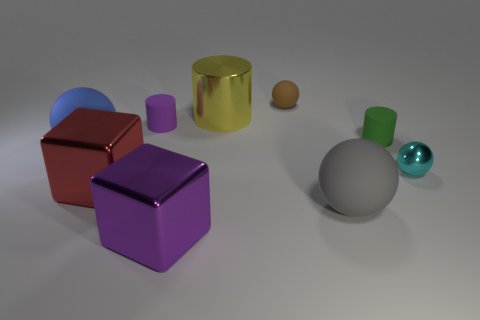What might the size relationships between the objects tell us? The size relationships suggest an interesting interplay of scale—some objects like the large gray sphere and purple cube might be considered central focal points due to their size, while smaller ones like the teal and wooden spheres might be viewed as complementary or accent pieces. 